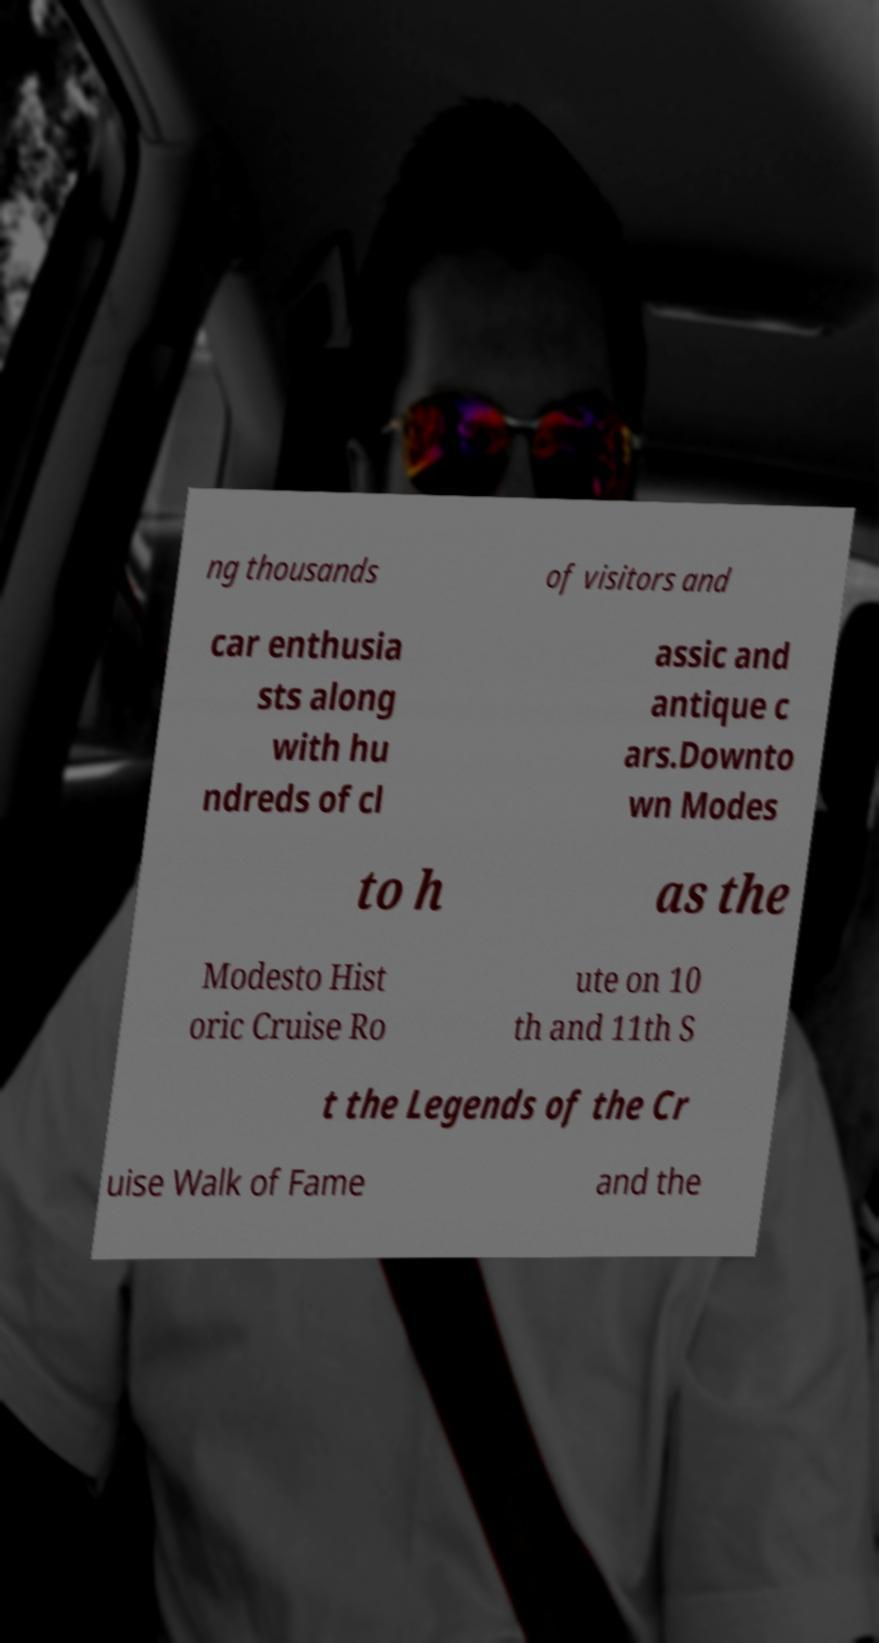Could you assist in decoding the text presented in this image and type it out clearly? ng thousands of visitors and car enthusia sts along with hu ndreds of cl assic and antique c ars.Downto wn Modes to h as the Modesto Hist oric Cruise Ro ute on 10 th and 11th S t the Legends of the Cr uise Walk of Fame and the 